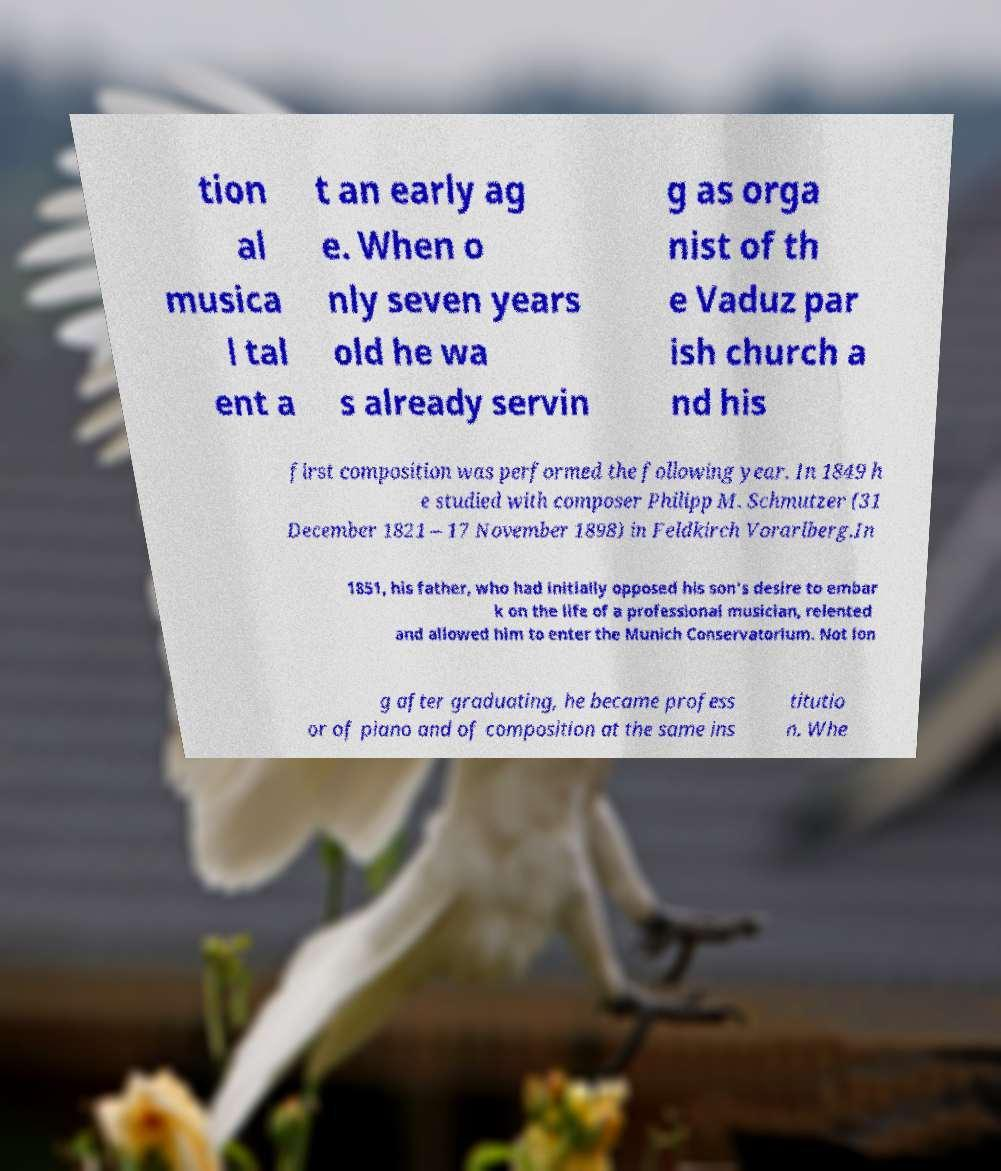I need the written content from this picture converted into text. Can you do that? tion al musica l tal ent a t an early ag e. When o nly seven years old he wa s already servin g as orga nist of th e Vaduz par ish church a nd his first composition was performed the following year. In 1849 h e studied with composer Philipp M. Schmutzer (31 December 1821 – 17 November 1898) in Feldkirch Vorarlberg.In 1851, his father, who had initially opposed his son's desire to embar k on the life of a professional musician, relented and allowed him to enter the Munich Conservatorium. Not lon g after graduating, he became profess or of piano and of composition at the same ins titutio n. Whe 